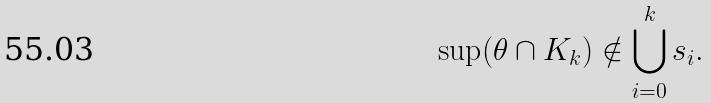Convert formula to latex. <formula><loc_0><loc_0><loc_500><loc_500>\sup ( \theta \cap K _ { k } ) \notin \bigcup _ { i = 0 } ^ { k } s _ { i } .</formula> 